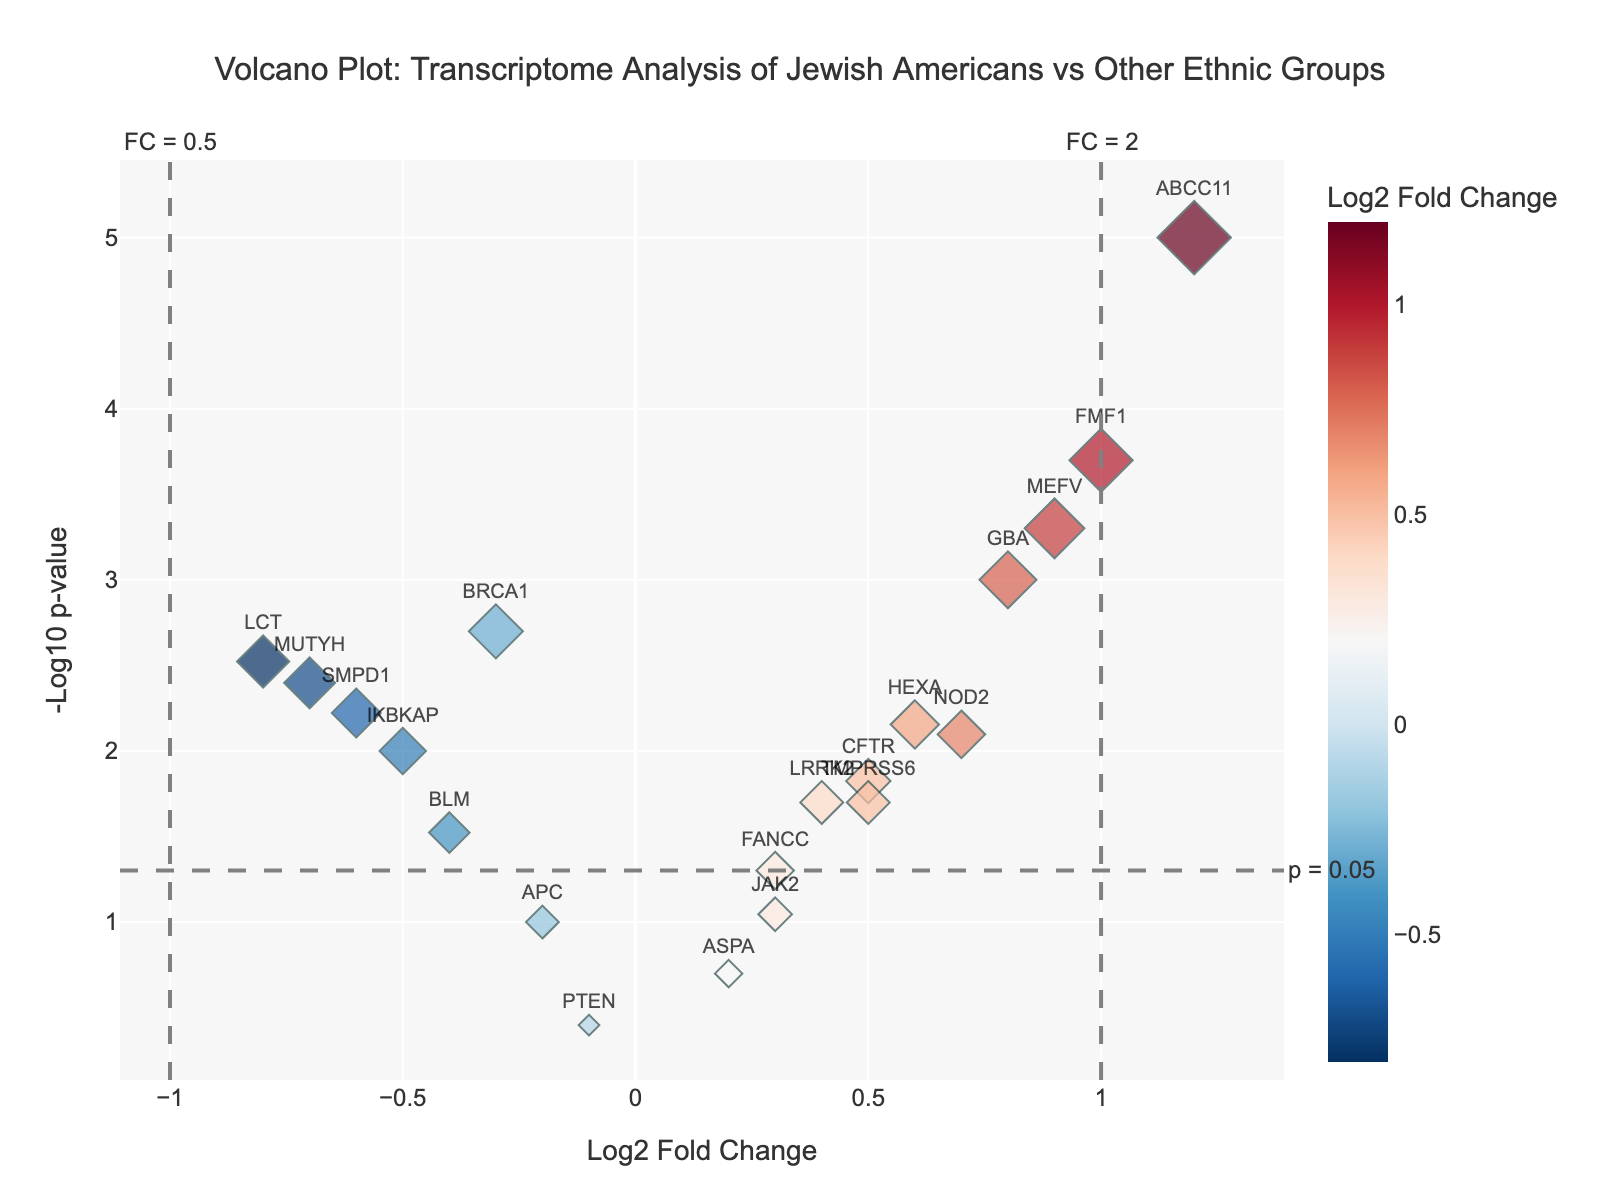What does the title of the plot say? The title of the plot is usually found at the top and provides a quick summary of what is being displayed. In this case, it explains the focus of the analysis.
Answer: The title is "Volcano Plot: Transcriptome Analysis of Jewish Americans vs Other Ethnic Groups" What do the x-axis and y-axis represent? In a volcano plot, the axes usually represent the fold change and the p-value of genes.
Answer: The x-axis represents "Log2 Fold Change" and the y-axis represents "-Log10 p-value" How many genes have a log2 fold change greater than 1? To determine this, look for data points to the right of the line x=1.
Answer: Three genes have a log2 fold change greater than 1 Which gene has the highest -log10(p-value) and what is the value? Identify the point that is highest on the y-axis, which indicates the most statistically significant result.
Answer: The gene ABCC11 has the highest -log10(p-value) of 5 Which genes have a negative log2 fold change but are highly statistically significant? Look for genes with log2 fold change less than 0 and -log10(p-value) significantly high, above dashed horizontal line y=-log10(0.05).
Answer: BRCA1, LCT, IKBKAP, SMPD1, MUTYH What thresholds are indicated by the dashed lines? The plot usually includes thresholds for fold change and p-value significance. The dashed lines mark these values.
Answer: The dashed lines for x-axis indicate fold change thresholds at 1 and -1, and the dashed line for y-axis indicates a p-value threshold at -log10(0.05) Which genes are comparatively least differential in their expression (close to zero log2 fold change)? Look for data points around the zero mark on the x-axis.
Answer: PTEN, ASPA How many genes have a p-value less than 0.01? Look for data points above the -log10(0.01) value on the y-axis.
Answer: Nine genes have a p-value less than 0.01 Which gene has the smallest log2 fold change among those that are statistically significant (-log10(p-value) > 1.3)? Focus on genes with -log10(pvalue) > 1.3 and identify the smallest log2 fold change among them.
Answer: BRCA1 has the smallest log2 fold change among the significant ones at -0.3 Which gene is displayed closest to the top left corner, and what does it imply about this gene's expression? The top left corner combines high statistical significance and large negative fold change.
Answer: LCT is closest to the top left, meaning it is highly statistically significant with lower expression in Jewish Americans compared to other ethnic groups 